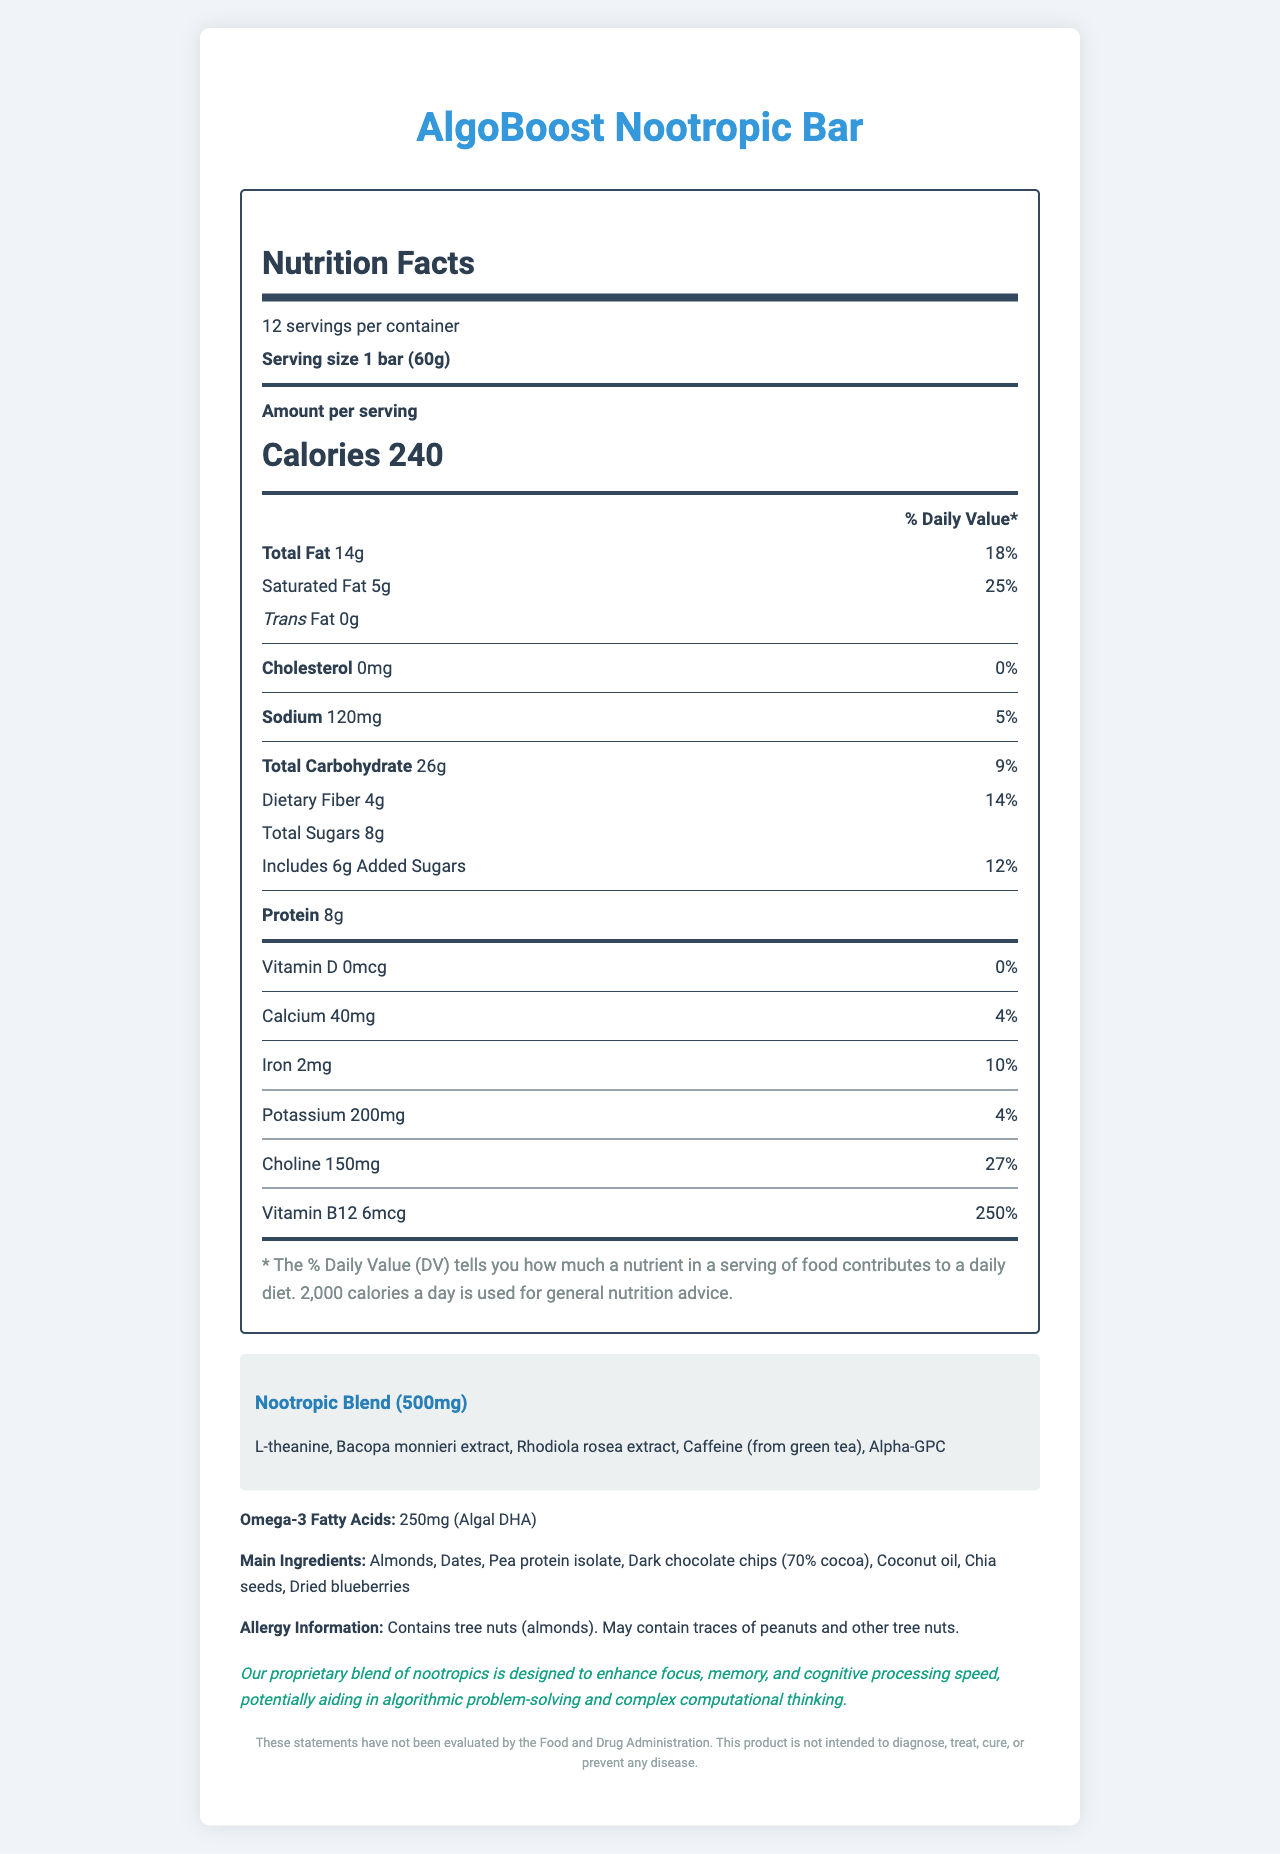what is the serving size of the AlgoBoost Nootropic Bar? The serving size is explicitly mentioned as "1 bar (60g)" in the Nutrition Facts label.
Answer: 1 bar (60g) how many servings are there per container? The label states that there are 12 servings per container.
Answer: 12 what are the total calories per serving? The label indicates that each serving contains 240 calories.
Answer: 240 which ingredient provides omega-3 fatty acids in the bar? The document specifies that "Algal DHA" is the source of Omega-3 fatty acids.
Answer: Algal DHA how much protein is in one serving? The nutrition label lists the protein content per serving as 8g.
Answer: 8g how much added sugar is in one serving? The section showing added sugars lists 6g for each serving.
Answer: 6g Which of the following is not part of the nootropic blend in the AlgoBoost Nootropic Bar?
A. L-theanine
B. Bacopa monnieri extract
C. Dark chocolate chips
D. Rhodiola rosea extract The nootropic blend includes L-theanine, Bacopa monnieri extract, Rhodiola rosea extract, caffeine (from green tea), and Alpha-GPC, whereas Dark chocolate chips are listed as a main ingredient but not part of the nootropic blend.
Answer: C. Dark chocolate chips What is the primary purpose of the AlgoBoost Nootropic Bar?
A. Weight loss
B. Promoting muscle growth
C. Enhancing cognitive function
D. Reducing cholesterol The claim section of the label states that the bar is designed to enhance focus, memory, and cognitive processing speed, which aids in cognitive function.
Answer: C. Enhancing cognitive function Is the product designed to treat or prevent any diseases? The disclaimer clearly states that the product is not intended to diagnose, treat, cure, or prevent any disease.
Answer: No summarize the key nutritional benefits and claims of the AlgoBoost Nootropic Bar. The document includes detailed information about the nutritional content, including macronutrients, vitamins, and minerals. It highlights the proprietary nootropic blend intended to enhance cognitive functions. The summary captures these focal aspects along with the claim and disclaimer.
Answer: The AlgoBoost Nootropic Bar offers various nutritional benefits including 8g of protein, 4g of dietary fiber, and essential vitamins like B12. It contains a proprietary nootropic blend aimed at enhancing focus, memory, and cognitive processing speed, which may aid in algorithmic thinking. The bar is also rich in omega-3 fatty acids from Algal DHA and provides a good amount of choline. Additionally, it has 240 calories per serving, and includes healthy ingredients such as almonds, dates, pea protein isolate, and more. However, the product is not intended to diagnose, treat, cure, or prevent diseases. What percentage of the daily value of Vitamin B12 is provided by one serving of the bar? The nutrition label indicates that one serving provides 250% of the daily value for Vitamin B12.
Answer: 250% How much cholesterol is in each serving of the AlgoBoost Nootropic Bar? The label explicitly shows that each serving contains 0mg of cholesterol.
Answer: 0mg How many grams of total fat are in a single serving? The nutrition label lists the total fat per serving as 14g.
Answer: 14g What are the main ingredients of the bar? The document lists these items as the main ingredients.
Answer: Almonds, Dates, Pea protein isolate, Dark chocolate chips (70% cocoa), Coconut oil, Chia seeds, Dried blueberries Is the product certified by the FDA? The label includes a disclaimer that states the product's claims have not been evaluated by the Food and Drug Administration, but it does not provide information on FDA certification.
Answer: Cannot be determined How many milligrams of iron are in one serving? The nutrition label indicates that each serving contains 2mg of iron.
Answer: 2mg What kind of fat is entirely absent in this snack bar? The label clearly states that the bar contains 0g of trans fat across all servings.
Answer: Trans fat 